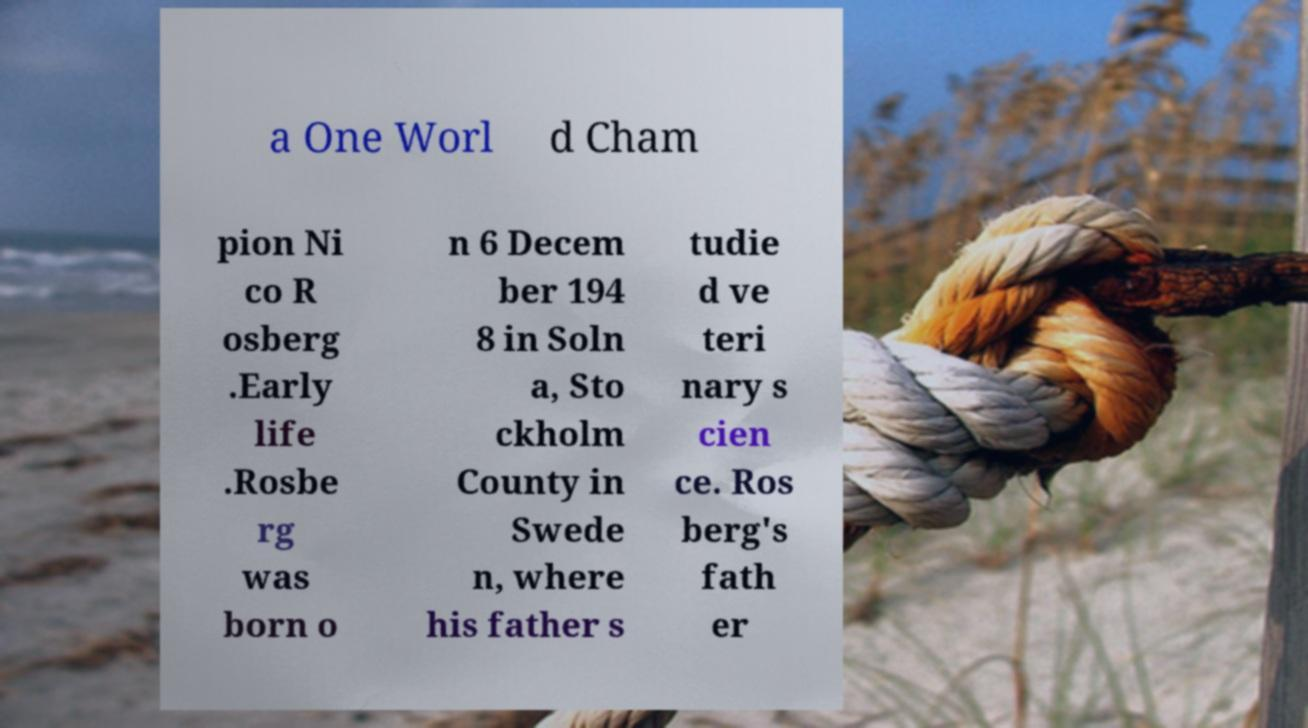What messages or text are displayed in this image? I need them in a readable, typed format. a One Worl d Cham pion Ni co R osberg .Early life .Rosbe rg was born o n 6 Decem ber 194 8 in Soln a, Sto ckholm County in Swede n, where his father s tudie d ve teri nary s cien ce. Ros berg's fath er 